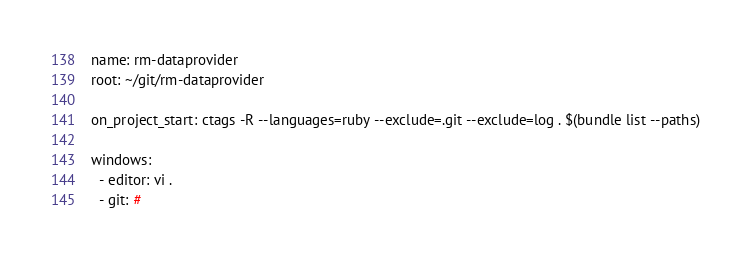Convert code to text. <code><loc_0><loc_0><loc_500><loc_500><_YAML_>name: rm-dataprovider
root: ~/git/rm-dataprovider

on_project_start: ctags -R --languages=ruby --exclude=.git --exclude=log . $(bundle list --paths)

windows:
  - editor: vi .
  - git: # 
</code> 